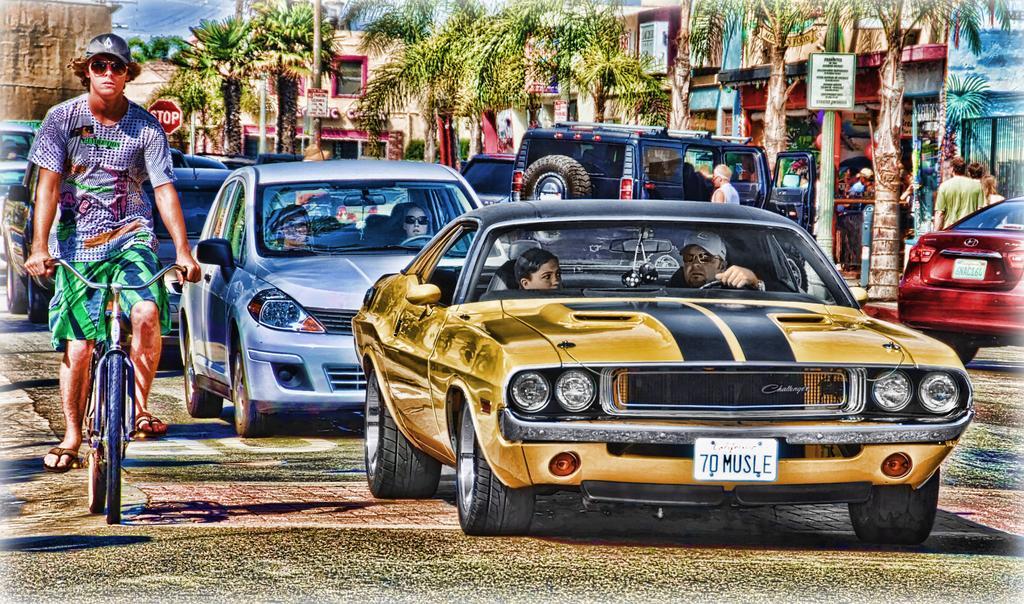In one or two sentences, can you explain what this image depicts? In this picture there is a man riding a bicycle. There are some cars , persons sitting in it. There is a number plate on the car. There are some trees and buildings at the background. 